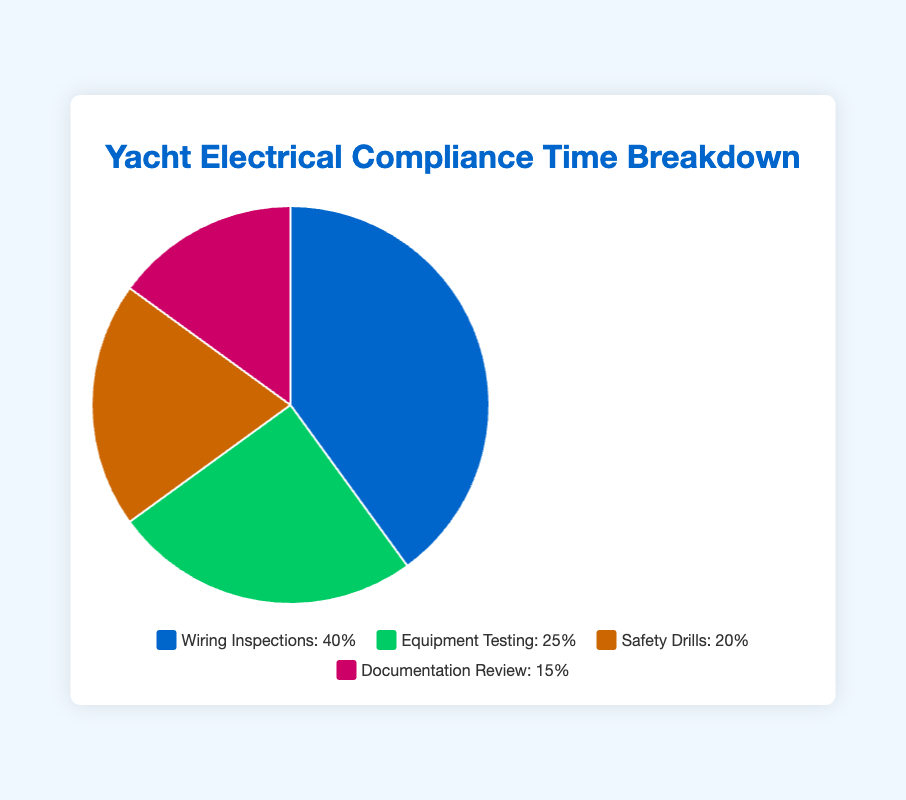What percentage of time is spent on Equipment Testing? Refer to the pie chart, where each category's percentage is shown. The segment labeled "Equipment Testing" has 25%.
Answer: 25% Which compliance check category consumes the most time? Look at the pie chart's largest segment. "Wiring Inspections" covers the largest area, indicating it consumes 40%, the highest among all categories.
Answer: Wiring Inspections How much more time is spent on Wiring Inspections compared to Documentation Review? Subtract the percentage of Documentation Review from Wiring Inspections: 40% - 15% = 25%. Thus, Wiring Inspections consume 25% more time than Documentation Review.
Answer: 25% What is the total percentage of time spent on activities that are not related to Equipment Testing? Add the percentages of all other activities: Wiring Inspections (40%) + Safety Drills (20%) + Documentation Review (15%) = 75%.
Answer: 75% Which activity is assigned the least amount of time? Identify the smallest segment in the pie chart. The "Documentation Review" segment is the smallest at 15%.
Answer: Documentation Review Compare the time spent on Safety Drills to the time spent on Equipment Testing. Refer to the chart: Safety Drills take 20%, while Equipment Testing takes 25%. Therefore, Equipment Testing takes 5% more time than Safety Drills.
Answer: Equipment Testing takes 5% more time Is the combined time spent on Safety Drills and Documentation Review greater than the time spent on Wiring Inspections? Add the percentages for Safety Drills and Documentation Review, then compare to Wiring Inspections: 20% + 15% = 35%, which is less than Wiring Inspections' 40%.
Answer: No What fraction of the total compliance checks time is spent on Safety Drills? The percentage for Safety Drills is 20%. Convert this to a fraction: 20%/100% = 1/5.
Answer: 1/5 What is the average percentage time spent on all activities? Add up all the percentages and divide by the number of categories: (40% + 25% + 20% + 15%) / 4 = 25%.
Answer: 25% What color represents Wiring Inspections in the pie chart? Refer to the pie chart. The largest segment, "Wiring Inspections," is shown in blue.
Answer: Blue 